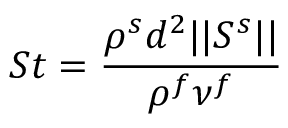<formula> <loc_0><loc_0><loc_500><loc_500>S t = \frac { \rho ^ { s } d ^ { 2 } | | S ^ { s } | | } { \rho ^ { f } \nu ^ { f } }</formula> 